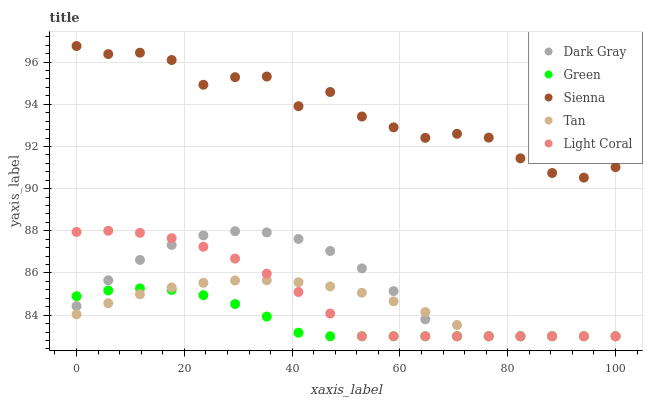Does Green have the minimum area under the curve?
Answer yes or no. Yes. Does Sienna have the maximum area under the curve?
Answer yes or no. Yes. Does Tan have the minimum area under the curve?
Answer yes or no. No. Does Tan have the maximum area under the curve?
Answer yes or no. No. Is Tan the smoothest?
Answer yes or no. Yes. Is Sienna the roughest?
Answer yes or no. Yes. Is Sienna the smoothest?
Answer yes or no. No. Is Tan the roughest?
Answer yes or no. No. Does Dark Gray have the lowest value?
Answer yes or no. Yes. Does Sienna have the lowest value?
Answer yes or no. No. Does Sienna have the highest value?
Answer yes or no. Yes. Does Tan have the highest value?
Answer yes or no. No. Is Green less than Sienna?
Answer yes or no. Yes. Is Sienna greater than Green?
Answer yes or no. Yes. Does Light Coral intersect Green?
Answer yes or no. Yes. Is Light Coral less than Green?
Answer yes or no. No. Is Light Coral greater than Green?
Answer yes or no. No. Does Green intersect Sienna?
Answer yes or no. No. 